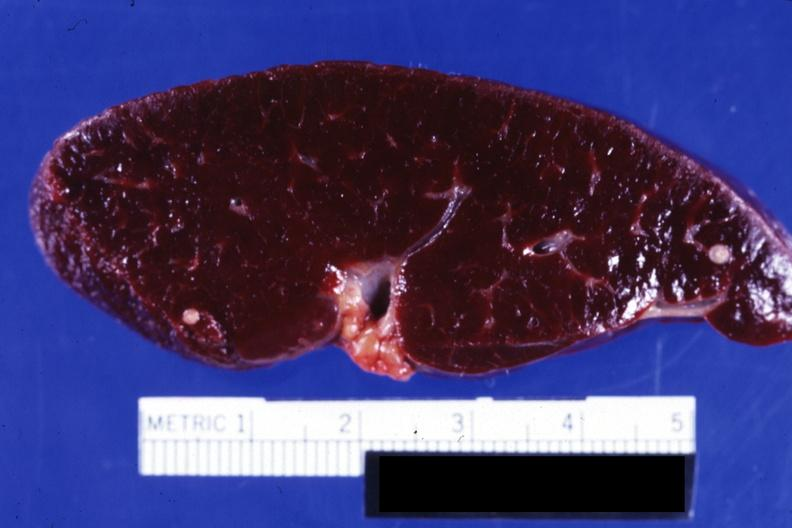s spleen present?
Answer the question using a single word or phrase. Yes 